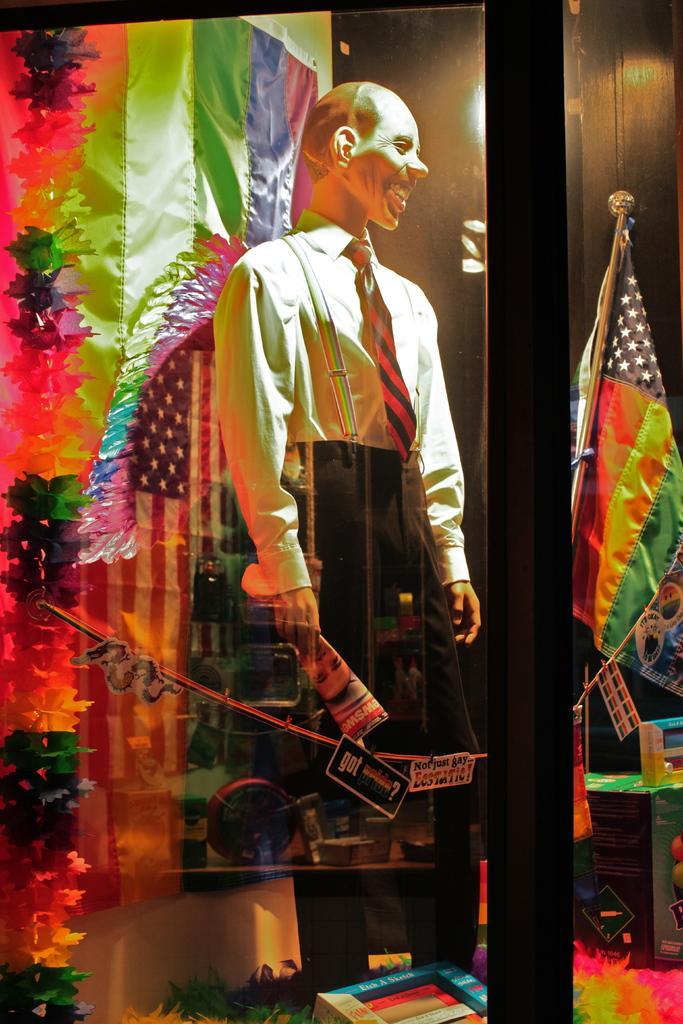Could you give a brief overview of what you see in this image? In this image I can see the glass through which I can see a mannequin wearing dress, a flag, a light and few colorful objects. 